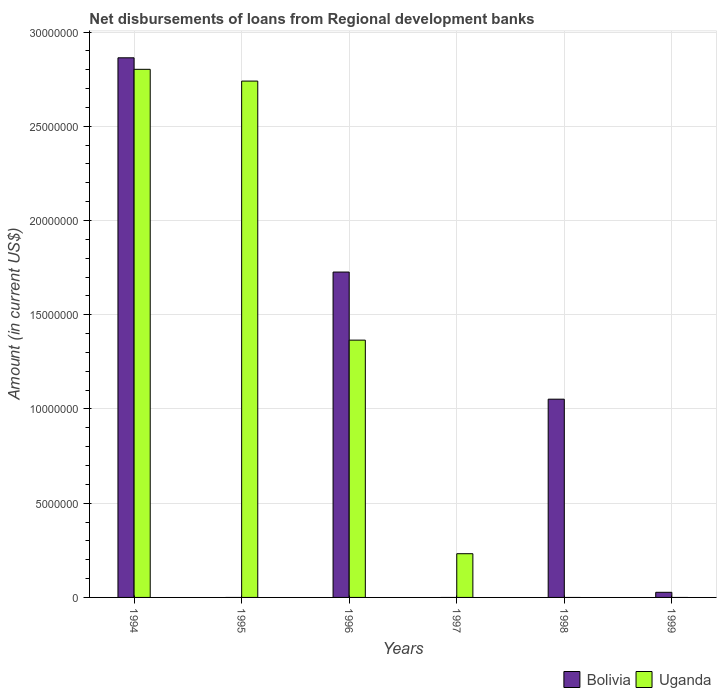Are the number of bars per tick equal to the number of legend labels?
Give a very brief answer. No. Are the number of bars on each tick of the X-axis equal?
Provide a short and direct response. No. What is the amount of disbursements of loans from regional development banks in Bolivia in 1998?
Provide a short and direct response. 1.05e+07. Across all years, what is the maximum amount of disbursements of loans from regional development banks in Uganda?
Make the answer very short. 2.80e+07. Across all years, what is the minimum amount of disbursements of loans from regional development banks in Uganda?
Your answer should be compact. 0. In which year was the amount of disbursements of loans from regional development banks in Uganda maximum?
Your answer should be very brief. 1994. What is the total amount of disbursements of loans from regional development banks in Uganda in the graph?
Provide a short and direct response. 7.14e+07. What is the difference between the amount of disbursements of loans from regional development banks in Bolivia in 1998 and that in 1999?
Offer a terse response. 1.02e+07. What is the difference between the amount of disbursements of loans from regional development banks in Uganda in 1997 and the amount of disbursements of loans from regional development banks in Bolivia in 1996?
Provide a short and direct response. -1.49e+07. What is the average amount of disbursements of loans from regional development banks in Bolivia per year?
Offer a very short reply. 9.45e+06. In the year 1996, what is the difference between the amount of disbursements of loans from regional development banks in Bolivia and amount of disbursements of loans from regional development banks in Uganda?
Give a very brief answer. 3.61e+06. In how many years, is the amount of disbursements of loans from regional development banks in Bolivia greater than 9000000 US$?
Your answer should be very brief. 3. What is the ratio of the amount of disbursements of loans from regional development banks in Uganda in 1996 to that in 1997?
Provide a short and direct response. 5.88. What is the difference between the highest and the second highest amount of disbursements of loans from regional development banks in Bolivia?
Your answer should be compact. 1.14e+07. What is the difference between the highest and the lowest amount of disbursements of loans from regional development banks in Bolivia?
Make the answer very short. 2.86e+07. In how many years, is the amount of disbursements of loans from regional development banks in Bolivia greater than the average amount of disbursements of loans from regional development banks in Bolivia taken over all years?
Your answer should be compact. 3. How many years are there in the graph?
Offer a very short reply. 6. Are the values on the major ticks of Y-axis written in scientific E-notation?
Make the answer very short. No. How many legend labels are there?
Provide a succinct answer. 2. How are the legend labels stacked?
Your answer should be compact. Horizontal. What is the title of the graph?
Your answer should be compact. Net disbursements of loans from Regional development banks. What is the label or title of the X-axis?
Give a very brief answer. Years. What is the label or title of the Y-axis?
Your answer should be compact. Amount (in current US$). What is the Amount (in current US$) in Bolivia in 1994?
Make the answer very short. 2.86e+07. What is the Amount (in current US$) in Uganda in 1994?
Provide a succinct answer. 2.80e+07. What is the Amount (in current US$) in Uganda in 1995?
Give a very brief answer. 2.74e+07. What is the Amount (in current US$) of Bolivia in 1996?
Ensure brevity in your answer.  1.73e+07. What is the Amount (in current US$) in Uganda in 1996?
Provide a succinct answer. 1.37e+07. What is the Amount (in current US$) of Bolivia in 1997?
Offer a very short reply. 0. What is the Amount (in current US$) in Uganda in 1997?
Your answer should be very brief. 2.32e+06. What is the Amount (in current US$) in Bolivia in 1998?
Make the answer very short. 1.05e+07. What is the Amount (in current US$) in Uganda in 1998?
Offer a very short reply. 0. What is the Amount (in current US$) in Bolivia in 1999?
Keep it short and to the point. 2.72e+05. Across all years, what is the maximum Amount (in current US$) of Bolivia?
Your answer should be very brief. 2.86e+07. Across all years, what is the maximum Amount (in current US$) of Uganda?
Make the answer very short. 2.80e+07. Across all years, what is the minimum Amount (in current US$) in Bolivia?
Your response must be concise. 0. Across all years, what is the minimum Amount (in current US$) in Uganda?
Make the answer very short. 0. What is the total Amount (in current US$) of Bolivia in the graph?
Your answer should be compact. 5.67e+07. What is the total Amount (in current US$) in Uganda in the graph?
Provide a succinct answer. 7.14e+07. What is the difference between the Amount (in current US$) of Uganda in 1994 and that in 1995?
Offer a very short reply. 6.24e+05. What is the difference between the Amount (in current US$) of Bolivia in 1994 and that in 1996?
Provide a short and direct response. 1.14e+07. What is the difference between the Amount (in current US$) in Uganda in 1994 and that in 1996?
Give a very brief answer. 1.44e+07. What is the difference between the Amount (in current US$) of Uganda in 1994 and that in 1997?
Give a very brief answer. 2.57e+07. What is the difference between the Amount (in current US$) of Bolivia in 1994 and that in 1998?
Your answer should be compact. 1.81e+07. What is the difference between the Amount (in current US$) in Bolivia in 1994 and that in 1999?
Your answer should be compact. 2.84e+07. What is the difference between the Amount (in current US$) in Uganda in 1995 and that in 1996?
Offer a terse response. 1.37e+07. What is the difference between the Amount (in current US$) of Uganda in 1995 and that in 1997?
Provide a short and direct response. 2.51e+07. What is the difference between the Amount (in current US$) in Uganda in 1996 and that in 1997?
Your answer should be very brief. 1.13e+07. What is the difference between the Amount (in current US$) in Bolivia in 1996 and that in 1998?
Your response must be concise. 6.75e+06. What is the difference between the Amount (in current US$) in Bolivia in 1996 and that in 1999?
Give a very brief answer. 1.70e+07. What is the difference between the Amount (in current US$) of Bolivia in 1998 and that in 1999?
Make the answer very short. 1.02e+07. What is the difference between the Amount (in current US$) in Bolivia in 1994 and the Amount (in current US$) in Uganda in 1995?
Keep it short and to the point. 1.24e+06. What is the difference between the Amount (in current US$) in Bolivia in 1994 and the Amount (in current US$) in Uganda in 1996?
Your response must be concise. 1.50e+07. What is the difference between the Amount (in current US$) of Bolivia in 1994 and the Amount (in current US$) of Uganda in 1997?
Your answer should be very brief. 2.63e+07. What is the difference between the Amount (in current US$) of Bolivia in 1996 and the Amount (in current US$) of Uganda in 1997?
Offer a terse response. 1.49e+07. What is the average Amount (in current US$) in Bolivia per year?
Offer a terse response. 9.45e+06. What is the average Amount (in current US$) in Uganda per year?
Offer a terse response. 1.19e+07. In the year 1994, what is the difference between the Amount (in current US$) in Bolivia and Amount (in current US$) in Uganda?
Provide a succinct answer. 6.11e+05. In the year 1996, what is the difference between the Amount (in current US$) of Bolivia and Amount (in current US$) of Uganda?
Offer a very short reply. 3.61e+06. What is the ratio of the Amount (in current US$) in Uganda in 1994 to that in 1995?
Keep it short and to the point. 1.02. What is the ratio of the Amount (in current US$) of Bolivia in 1994 to that in 1996?
Offer a terse response. 1.66. What is the ratio of the Amount (in current US$) of Uganda in 1994 to that in 1996?
Make the answer very short. 2.05. What is the ratio of the Amount (in current US$) of Uganda in 1994 to that in 1997?
Give a very brief answer. 12.08. What is the ratio of the Amount (in current US$) of Bolivia in 1994 to that in 1998?
Ensure brevity in your answer.  2.72. What is the ratio of the Amount (in current US$) in Bolivia in 1994 to that in 1999?
Offer a very short reply. 105.27. What is the ratio of the Amount (in current US$) of Uganda in 1995 to that in 1996?
Offer a terse response. 2.01. What is the ratio of the Amount (in current US$) in Uganda in 1995 to that in 1997?
Keep it short and to the point. 11.81. What is the ratio of the Amount (in current US$) of Uganda in 1996 to that in 1997?
Provide a short and direct response. 5.88. What is the ratio of the Amount (in current US$) in Bolivia in 1996 to that in 1998?
Make the answer very short. 1.64. What is the ratio of the Amount (in current US$) of Bolivia in 1996 to that in 1999?
Provide a short and direct response. 63.47. What is the ratio of the Amount (in current US$) in Bolivia in 1998 to that in 1999?
Offer a terse response. 38.67. What is the difference between the highest and the second highest Amount (in current US$) in Bolivia?
Provide a succinct answer. 1.14e+07. What is the difference between the highest and the second highest Amount (in current US$) of Uganda?
Your answer should be compact. 6.24e+05. What is the difference between the highest and the lowest Amount (in current US$) in Bolivia?
Provide a short and direct response. 2.86e+07. What is the difference between the highest and the lowest Amount (in current US$) in Uganda?
Ensure brevity in your answer.  2.80e+07. 